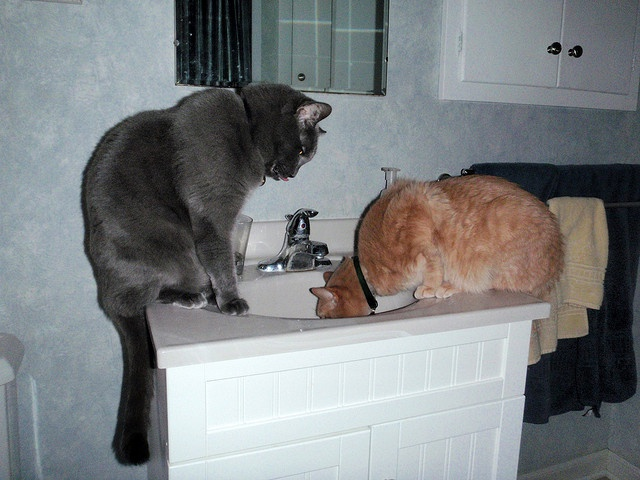Describe the objects in this image and their specific colors. I can see cat in gray, black, and darkgray tones, cat in gray, brown, and tan tones, sink in gray, darkgray, and lightgray tones, toilet in gray and darkgray tones, and cup in gray, darkgray, and black tones in this image. 